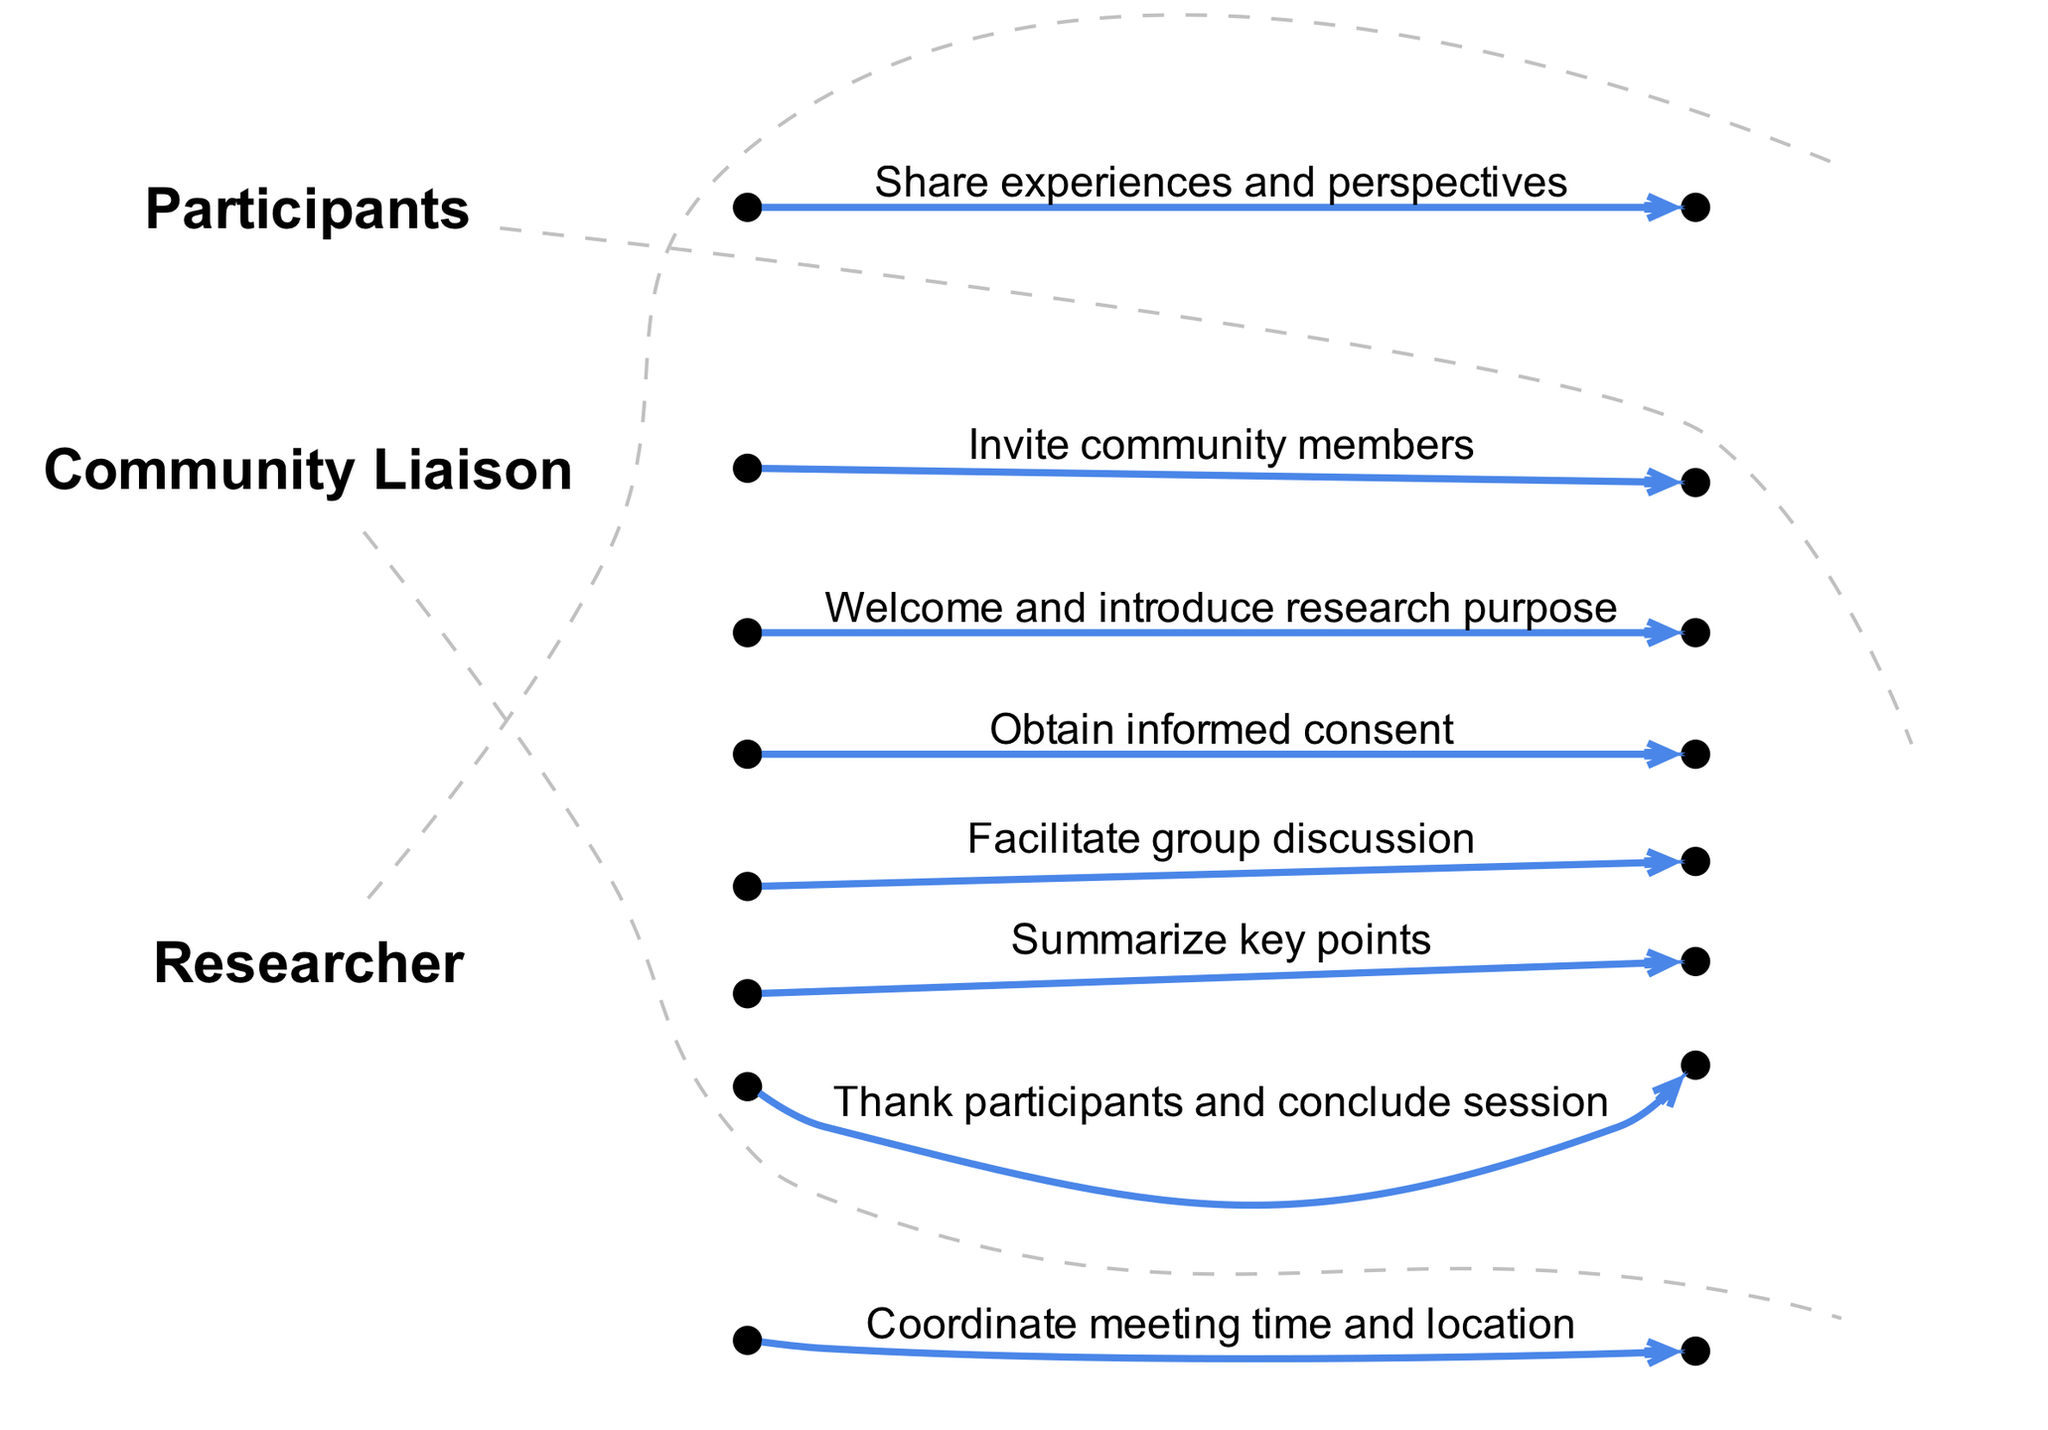What is the first action in the sequence? The first action noted in the sequence is between the Researcher and the Community Liaison, coordinating the meeting time and location.
Answer: Coordinate meeting time and location How many participants are involved in the discussion phase? During the discussion phase, all Participants are engaging with the Researcher, which implies all invited community members are included in that part of the session.
Answer: Participants Who invites the community members? The Community Liaison is responsible for inviting the community members, as indicated in the sequence.
Answer: Community Liaison How many messages are exchanged between the Researcher and Participants? The sequence shows three explicit messages exchanged between the Researcher and Participants: welcoming, obtaining consent, and facilitating discussion.
Answer: Three What is the last action taken in the session? The final action taken in the session is the Researcher thanking the participants and concluding the session, as shown at the end of the sequence.
Answer: Thank participants and conclude session Which actor summarizes the key points? The Researcher is the actor who summarizes the key points of the discussion, as specified in the sequence.
Answer: Researcher What type of interaction occurs between Participants and Researcher during the discussion phase? The type of interaction that occurs during the discussion phase is sharing experiences and perspectives, as evidenced in the sequence where Participants communicate with the Researcher.
Answer: Share experiences and perspectives How many total sequence steps are presented in the diagram? The diagram presents a total of eight sequence steps that outline the flow of actions during the focus group session.
Answer: Eight What type of consent is obtained from the Participants? The sequence explicitly mentions that informed consent is obtained from the Participants, which is crucial for ethical research practices.
Answer: Informed consent 